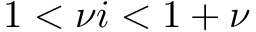<formula> <loc_0><loc_0><loc_500><loc_500>1 < \nu i < 1 + \nu</formula> 